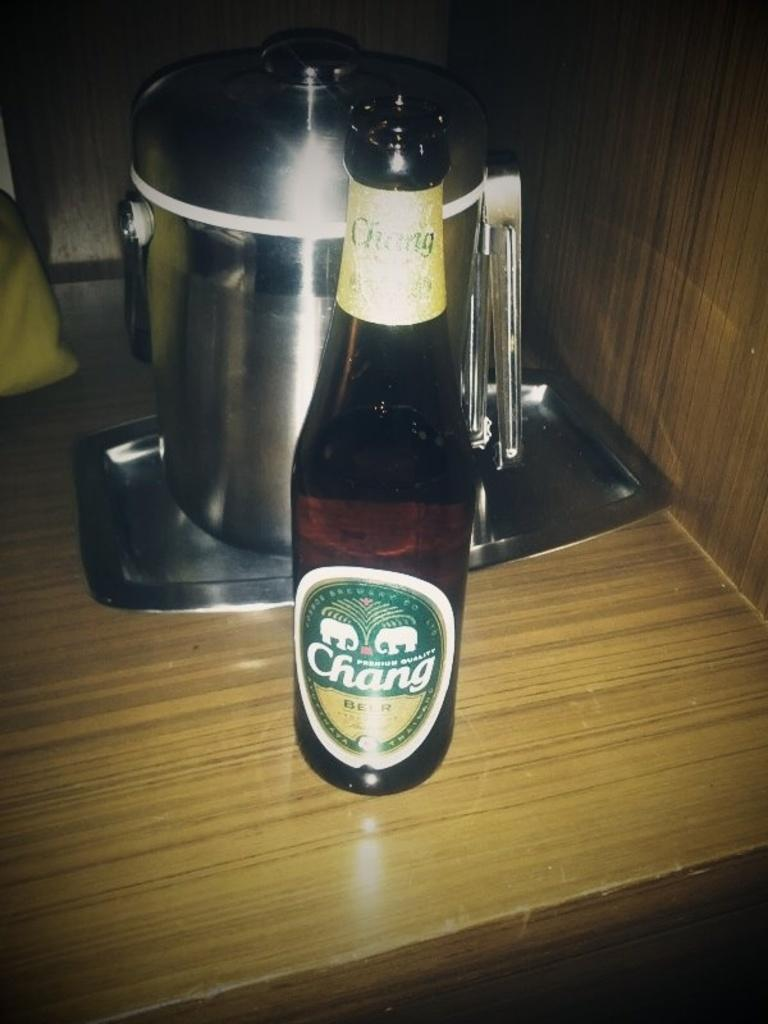<image>
Provide a brief description of the given image. A bottle with a Chang beer label in front of a silver pot. 